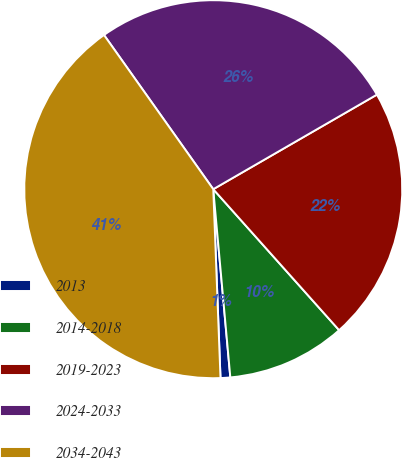<chart> <loc_0><loc_0><loc_500><loc_500><pie_chart><fcel>2013<fcel>2014-2018<fcel>2019-2023<fcel>2024-2033<fcel>2034-2043<nl><fcel>0.83%<fcel>10.16%<fcel>21.74%<fcel>26.47%<fcel>40.8%<nl></chart> 